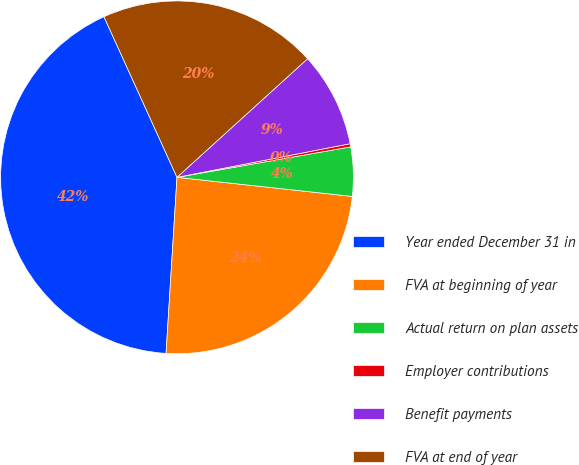<chart> <loc_0><loc_0><loc_500><loc_500><pie_chart><fcel>Year ended December 31 in<fcel>FVA at beginning of year<fcel>Actual return on plan assets<fcel>Employer contributions<fcel>Benefit payments<fcel>FVA at end of year<nl><fcel>42.22%<fcel>24.26%<fcel>4.49%<fcel>0.29%<fcel>8.68%<fcel>20.06%<nl></chart> 